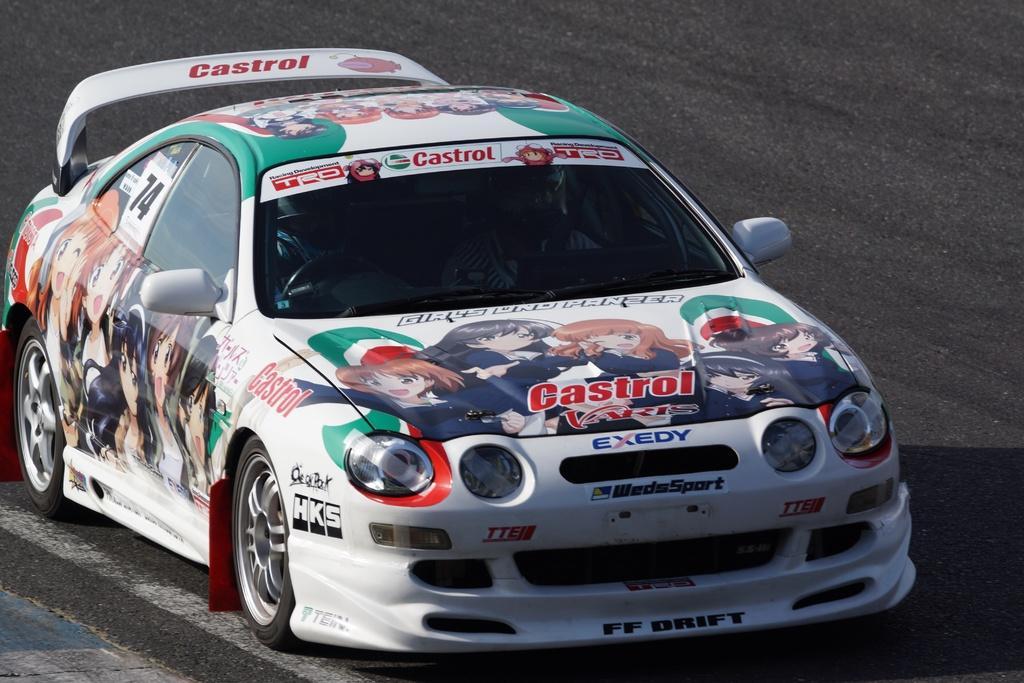Can you describe this image briefly? This is a car with the painting on it. I can see two people sitting inside the car. These are the wheels, side mirrors, headlights, bumper and car doors are attached to it. Here is a road. 